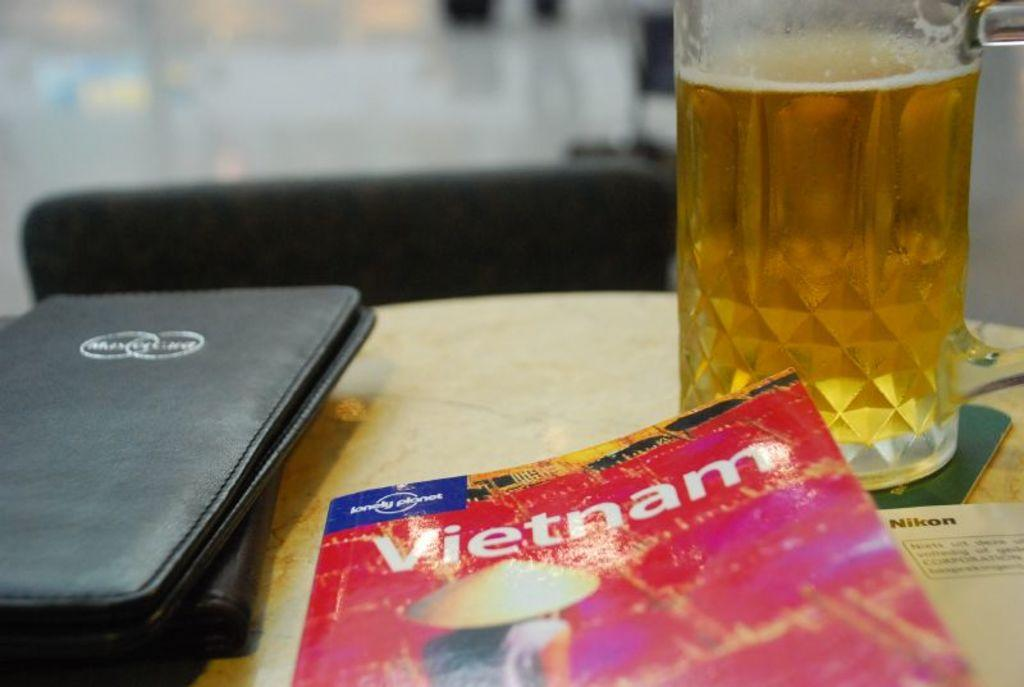<image>
Offer a succinct explanation of the picture presented. A table with a glass of beer,a receipt folder and a Vietnam book. 